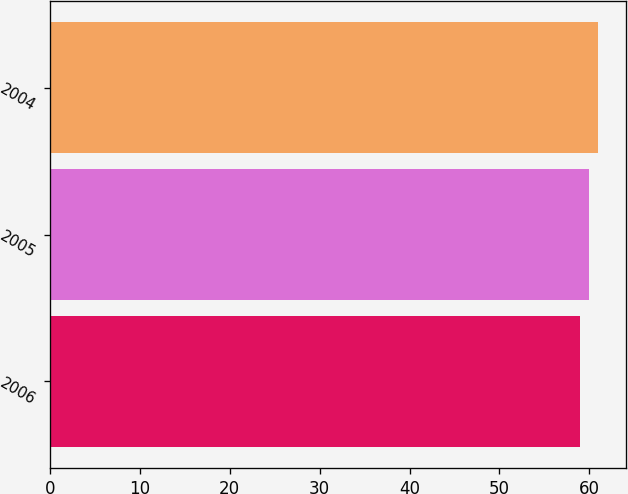<chart> <loc_0><loc_0><loc_500><loc_500><bar_chart><fcel>2006<fcel>2005<fcel>2004<nl><fcel>59<fcel>60<fcel>61<nl></chart> 